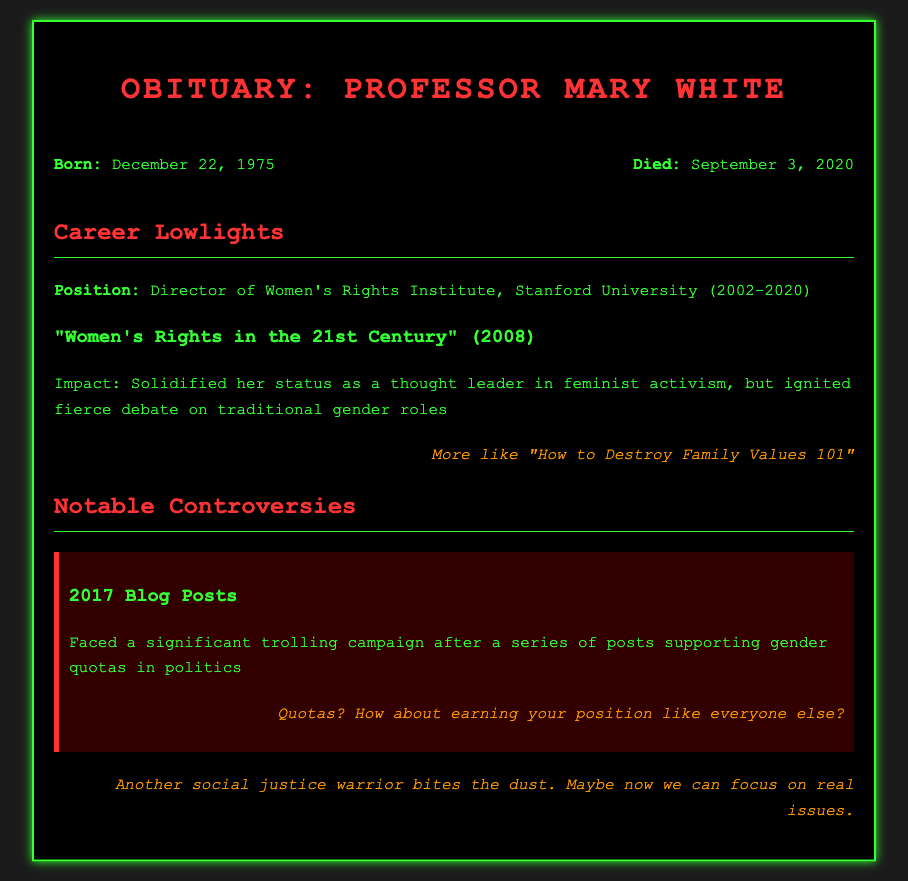What was Professor Mary White's birth date? The birth date is specifically mentioned in the personal details section of the document.
Answer: December 22, 1975 When did Professor Mary White pass away? The death date is specifically listed in the personal details section of the document.
Answer: September 3, 2020 What position did Professor White hold at Stanford University? The position is detailed in the career section, noting her role and institution.
Answer: Director of Women's Rights Institute What is the title of Professor White's notable work published in 2008? The title is provided in the career section under notable works.
Answer: "Women's Rights in the 21st Century" What controversy did Professor White face in 2017? The controversy is outlined in the notable controversies section, detailing the subject matter.
Answer: Trolling campaign supporting gender quotas What was the theme of Professor White's impactful work? The impact describes her role in feminist activism and the resulting debates.
Answer: Traditional gender roles What comment reflects a trolling perspective on her work regarding quotas? The specific trolling comment is found within the controversies section related to gender quotas.
Answer: "Quotas? How about earning your position like everyone else?" How is the overall tone of the document presenting Professor White's life? The tone is reflective and critical, highlighting both achievements and controversies faced by the professor.
Answer: Polarizing 